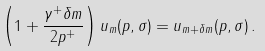<formula> <loc_0><loc_0><loc_500><loc_500>\left ( 1 + \frac { \gamma ^ { + } \delta m } { 2 p ^ { + } } \right ) u _ { m } ( p , \sigma ) = u _ { m + \delta m } ( p , \sigma ) \, .</formula> 